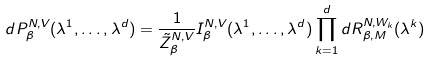Convert formula to latex. <formula><loc_0><loc_0><loc_500><loc_500>d P ^ { N , V } _ { \beta } ( \lambda ^ { 1 } , \dots , \lambda ^ { d } ) = \frac { 1 } { \tilde { Z } ^ { N , V } _ { \beta } } I ^ { N , V } _ { \beta } ( \lambda ^ { 1 } , \dots , \lambda ^ { d } ) \prod _ { k = 1 } ^ { d } d R ^ { N , W _ { k } } _ { \beta , M } ( \lambda ^ { k } )</formula> 